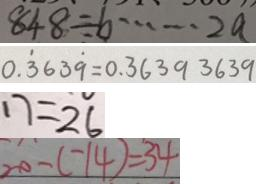Convert formula to latex. <formula><loc_0><loc_0><loc_500><loc_500>8 4 8 \div b \cdots 2 a 
 0 . \dot { 3 } 6 3 \dot { 9 } = 0 . 3 6 3 9 3 6 3 9 
 1 7 = 2 6 
 2 0 - ( - 1 4 ) = 3 4</formula> 